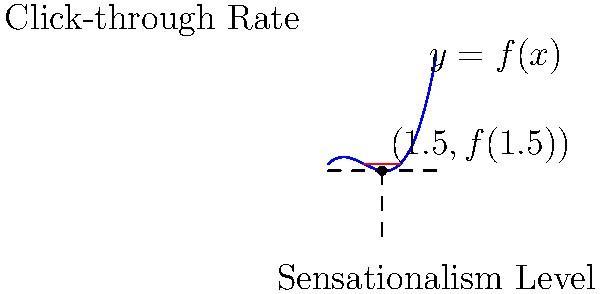Consider the curve $y = f(x)$ representing the relationship between the level of sensationalism in headlines (x-axis) and the click-through rate (y-axis). At the point where the sensationalism level is 1.5, the tangent line has a slope of 0.75. If $f(x) = ax^3 + bx^2 + cx + d$, determine the value of $a$. To solve this problem, we'll follow these steps:

1) The general form of the function is $f(x) = ax^3 + bx^2 + cx + d$.

2) The derivative of this function is $f'(x) = 3ax^2 + 2bx + c$.

3) We're told that at $x = 1.5$, the slope of the tangent line (which is equal to the derivative) is 0.75. So:

   $f'(1.5) = 3a(1.5)^2 + 2b(1.5) + c = 0.75$

4) We don't know the values of $b$ and $c$, but we can use the fact that the derivative at $x = 1.5$ is 0.75:

   $3a(1.5)^2 + 2b(1.5) + c = 0.75$
   $6.75a + 3b + c = 0.75$

5) This is one equation with three unknowns, so we can't solve it directly. However, we're only asked to find $a$.

6) The second derivative of $f(x)$ is $f''(x) = 6ax + 2b$.

7) The third derivative is a constant: $f'''(x) = 6a$.

8) Here's the key insight: the third derivative of a cubic function is always six times the coefficient of the cubic term. Therefore:

   $f'''(x) = 6a = 0.75$

9) Solving this:

   $a = 0.75 / 6 = 0.125$

Thus, the value of $a$ is 0.125.
Answer: $a = 0.125$ 